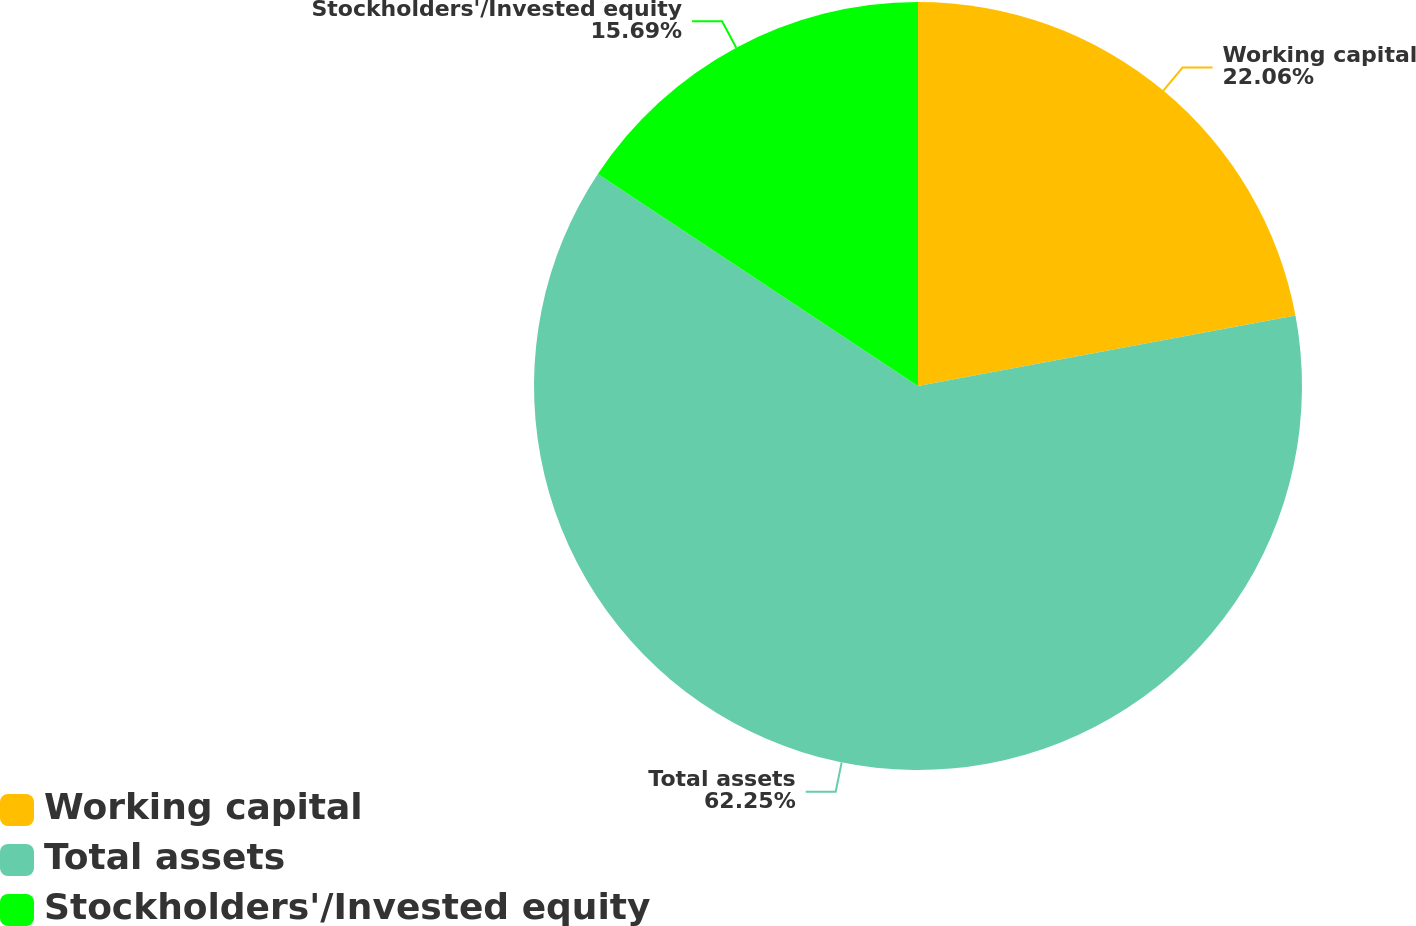<chart> <loc_0><loc_0><loc_500><loc_500><pie_chart><fcel>Working capital<fcel>Total assets<fcel>Stockholders'/Invested equity<nl><fcel>22.06%<fcel>62.24%<fcel>15.69%<nl></chart> 